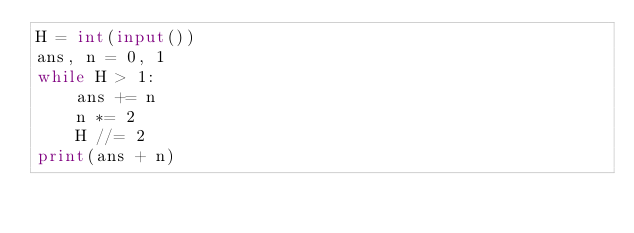<code> <loc_0><loc_0><loc_500><loc_500><_Python_>H = int(input())
ans, n = 0, 1
while H > 1:
    ans += n
    n *= 2
    H //= 2
print(ans + n)
</code> 